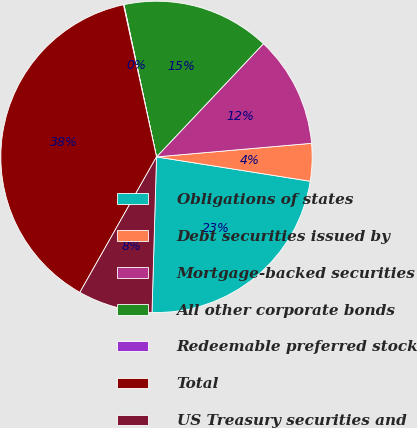Convert chart. <chart><loc_0><loc_0><loc_500><loc_500><pie_chart><fcel>Obligations of states<fcel>Debt securities issued by<fcel>Mortgage-backed securities<fcel>All other corporate bonds<fcel>Redeemable preferred stock<fcel>Total<fcel>US Treasury securities and<nl><fcel>22.96%<fcel>3.89%<fcel>11.56%<fcel>15.4%<fcel>0.06%<fcel>38.4%<fcel>7.73%<nl></chart> 